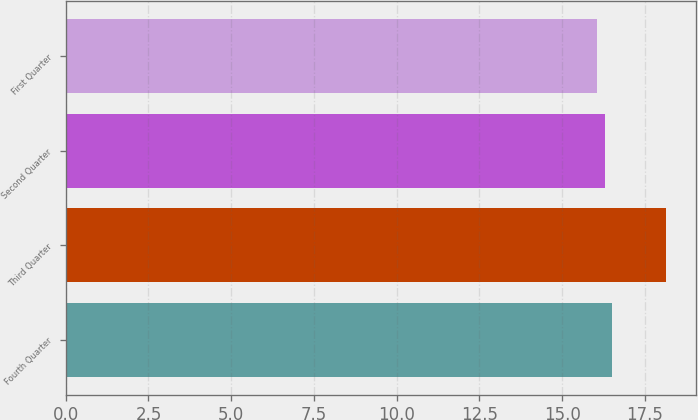Convert chart. <chart><loc_0><loc_0><loc_500><loc_500><bar_chart><fcel>Fourth Quarter<fcel>Third Quarter<fcel>Second Quarter<fcel>First Quarter<nl><fcel>16.51<fcel>18.14<fcel>16.28<fcel>16.05<nl></chart> 